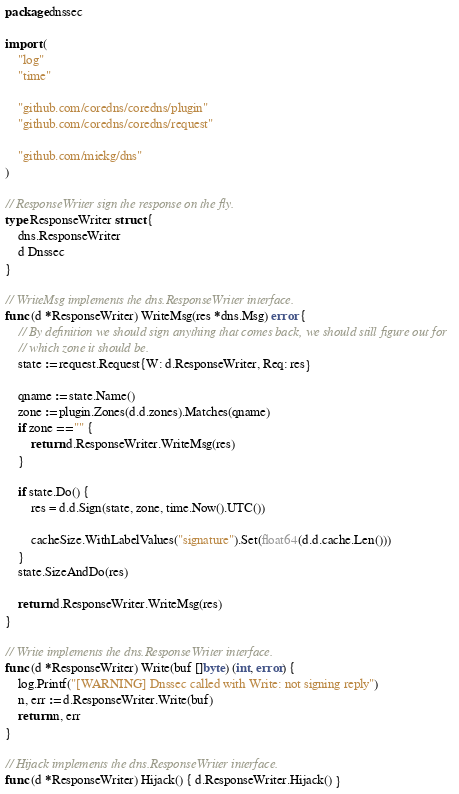Convert code to text. <code><loc_0><loc_0><loc_500><loc_500><_Go_>package dnssec

import (
	"log"
	"time"

	"github.com/coredns/coredns/plugin"
	"github.com/coredns/coredns/request"

	"github.com/miekg/dns"
)

// ResponseWriter sign the response on the fly.
type ResponseWriter struct {
	dns.ResponseWriter
	d Dnssec
}

// WriteMsg implements the dns.ResponseWriter interface.
func (d *ResponseWriter) WriteMsg(res *dns.Msg) error {
	// By definition we should sign anything that comes back, we should still figure out for
	// which zone it should be.
	state := request.Request{W: d.ResponseWriter, Req: res}

	qname := state.Name()
	zone := plugin.Zones(d.d.zones).Matches(qname)
	if zone == "" {
		return d.ResponseWriter.WriteMsg(res)
	}

	if state.Do() {
		res = d.d.Sign(state, zone, time.Now().UTC())

		cacheSize.WithLabelValues("signature").Set(float64(d.d.cache.Len()))
	}
	state.SizeAndDo(res)

	return d.ResponseWriter.WriteMsg(res)
}

// Write implements the dns.ResponseWriter interface.
func (d *ResponseWriter) Write(buf []byte) (int, error) {
	log.Printf("[WARNING] Dnssec called with Write: not signing reply")
	n, err := d.ResponseWriter.Write(buf)
	return n, err
}

// Hijack implements the dns.ResponseWriter interface.
func (d *ResponseWriter) Hijack() { d.ResponseWriter.Hijack() }
</code> 